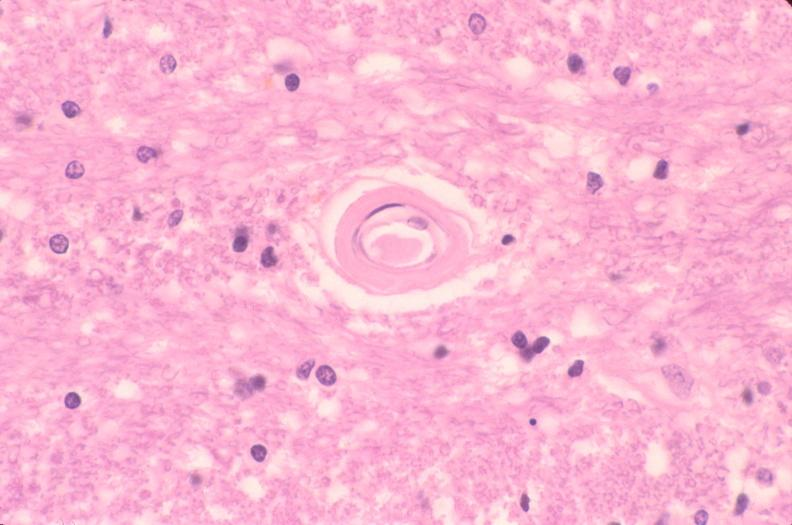s nervous present?
Answer the question using a single word or phrase. Yes 